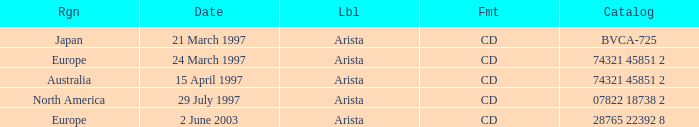What's listed for the Label with a Date of 29 July 1997? Arista. 